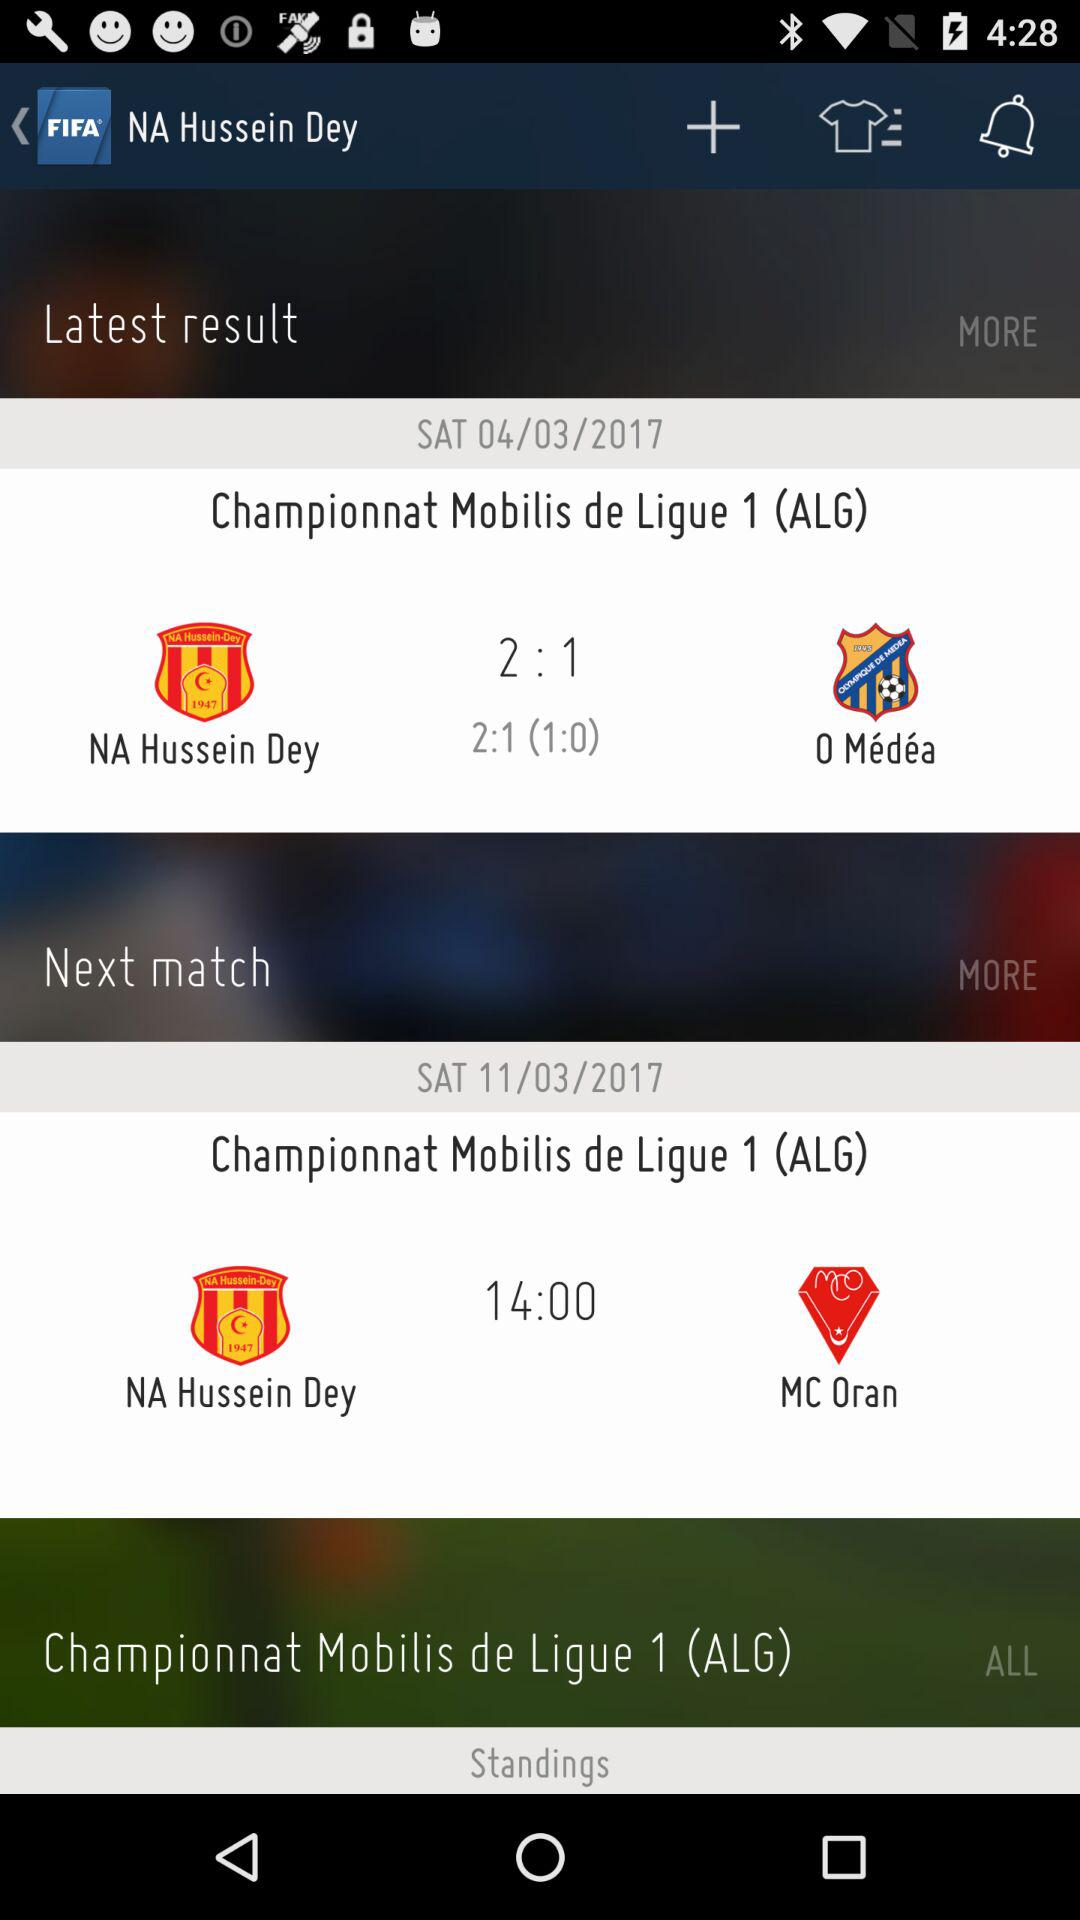How many more points did NA Hussein Dey score in the latest result than O Médéa?
Answer the question using a single word or phrase. 1 